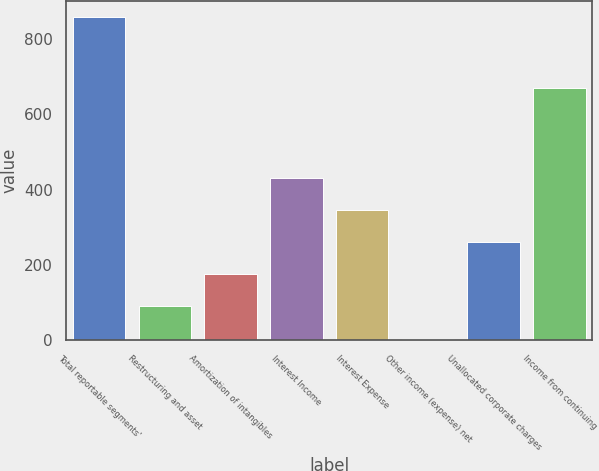Convert chart. <chart><loc_0><loc_0><loc_500><loc_500><bar_chart><fcel>Total reportable segments'<fcel>Restructuring and asset<fcel>Amortization of intangibles<fcel>Interest Income<fcel>Interest Expense<fcel>Other income (expense) net<fcel>Unallocated corporate charges<fcel>Income from continuing<nl><fcel>858<fcel>90.3<fcel>175.6<fcel>431.5<fcel>346.2<fcel>5<fcel>260.9<fcel>670<nl></chart> 